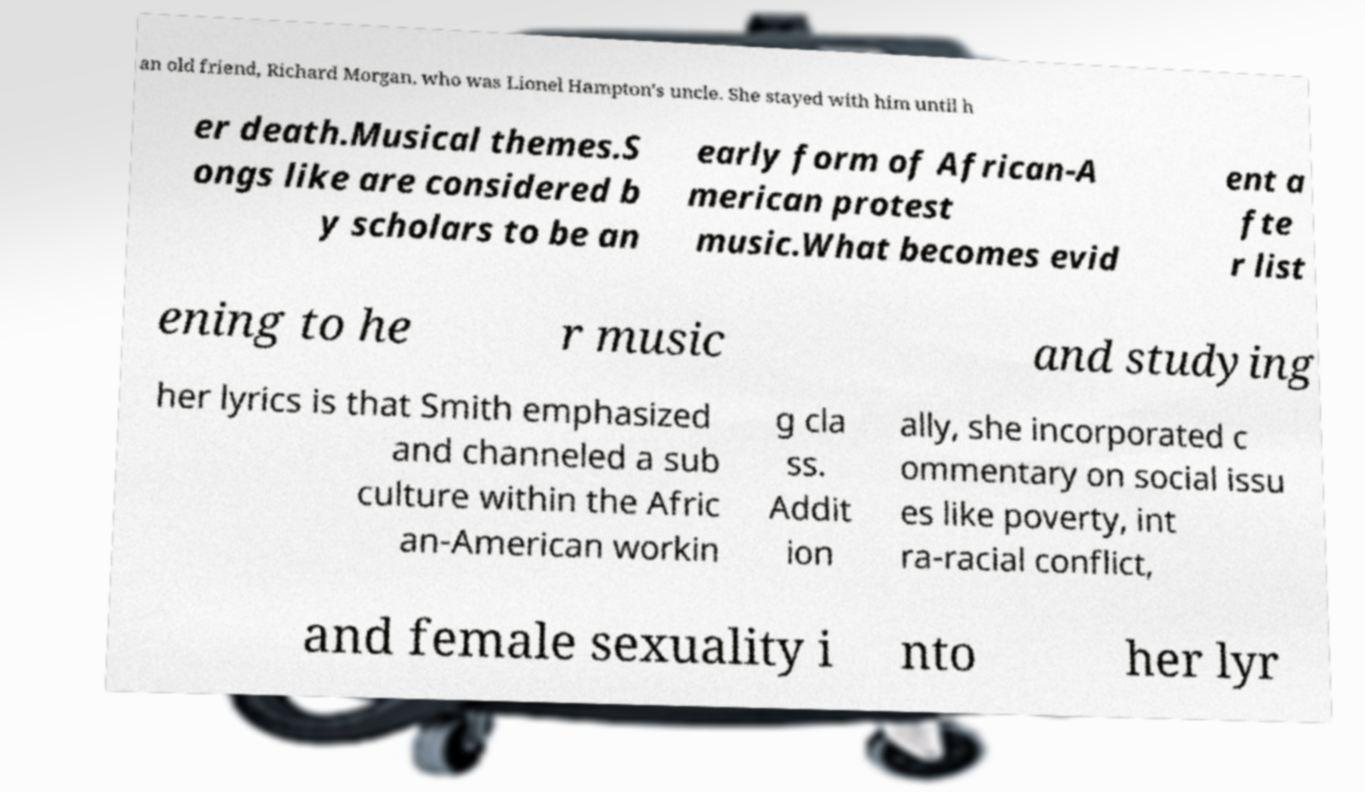Can you read and provide the text displayed in the image?This photo seems to have some interesting text. Can you extract and type it out for me? an old friend, Richard Morgan, who was Lionel Hampton's uncle. She stayed with him until h er death.Musical themes.S ongs like are considered b y scholars to be an early form of African-A merican protest music.What becomes evid ent a fte r list ening to he r music and studying her lyrics is that Smith emphasized and channeled a sub culture within the Afric an-American workin g cla ss. Addit ion ally, she incorporated c ommentary on social issu es like poverty, int ra-racial conflict, and female sexuality i nto her lyr 